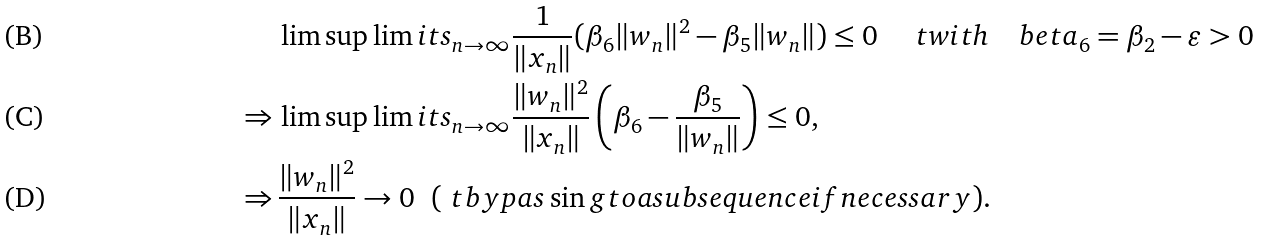<formula> <loc_0><loc_0><loc_500><loc_500>\ & \, \lim \sup \lim i t s _ { n \to \infty } \frac { 1 } { \| x _ { n } \| } ( \beta _ { 6 } \| w _ { n } \| ^ { 2 } - \beta _ { 5 } \| w _ { n } \| ) \leq 0 \quad \ t { w i t h } \quad b e t a _ { 6 } = \beta _ { 2 } - \varepsilon > 0 \\ \Rightarrow & \, \lim \sup \lim i t s _ { n \to \infty } \frac { \| w _ { n } \| ^ { 2 } } { \| x _ { n } \| } \left ( \beta _ { 6 } - \frac { \beta _ { 5 } } { \| w _ { n } \| } \right ) \leq 0 , \\ \Rightarrow & \, \frac { \| w _ { n } \| ^ { 2 } } { \| x _ { n } \| } \rightarrow 0 \ \ ( \ t { b y p a s \sin g t o a s u b s e q u e n c e i f n e c e s s a r y } ) .</formula> 